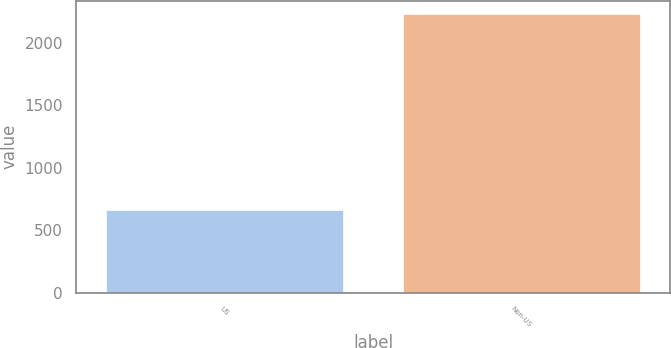<chart> <loc_0><loc_0><loc_500><loc_500><bar_chart><fcel>US<fcel>Non-US<nl><fcel>661<fcel>2227<nl></chart> 